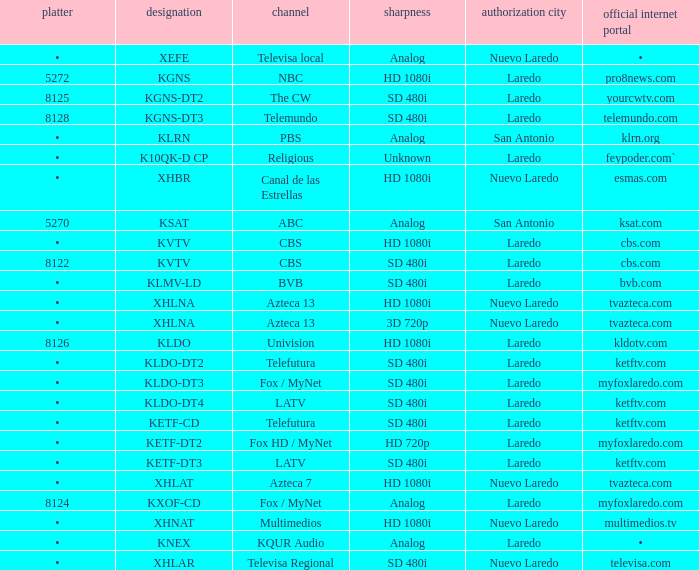Name the resolution for dish of 5270 Analog. 